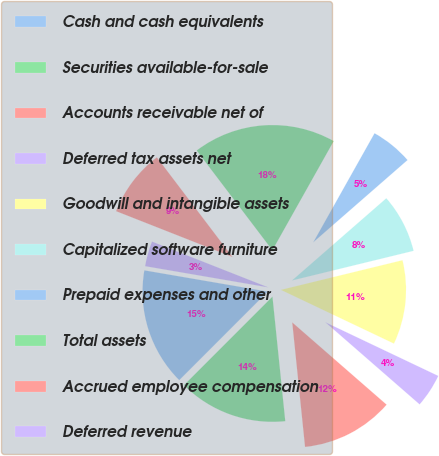<chart> <loc_0><loc_0><loc_500><loc_500><pie_chart><fcel>Cash and cash equivalents<fcel>Securities available-for-sale<fcel>Accounts receivable net of<fcel>Deferred tax assets net<fcel>Goodwill and intangible assets<fcel>Capitalized software furniture<fcel>Prepaid expenses and other<fcel>Total assets<fcel>Accrued employee compensation<fcel>Deferred revenue<nl><fcel>15.22%<fcel>14.13%<fcel>11.96%<fcel>4.35%<fcel>10.87%<fcel>7.61%<fcel>5.44%<fcel>18.48%<fcel>8.7%<fcel>3.26%<nl></chart> 